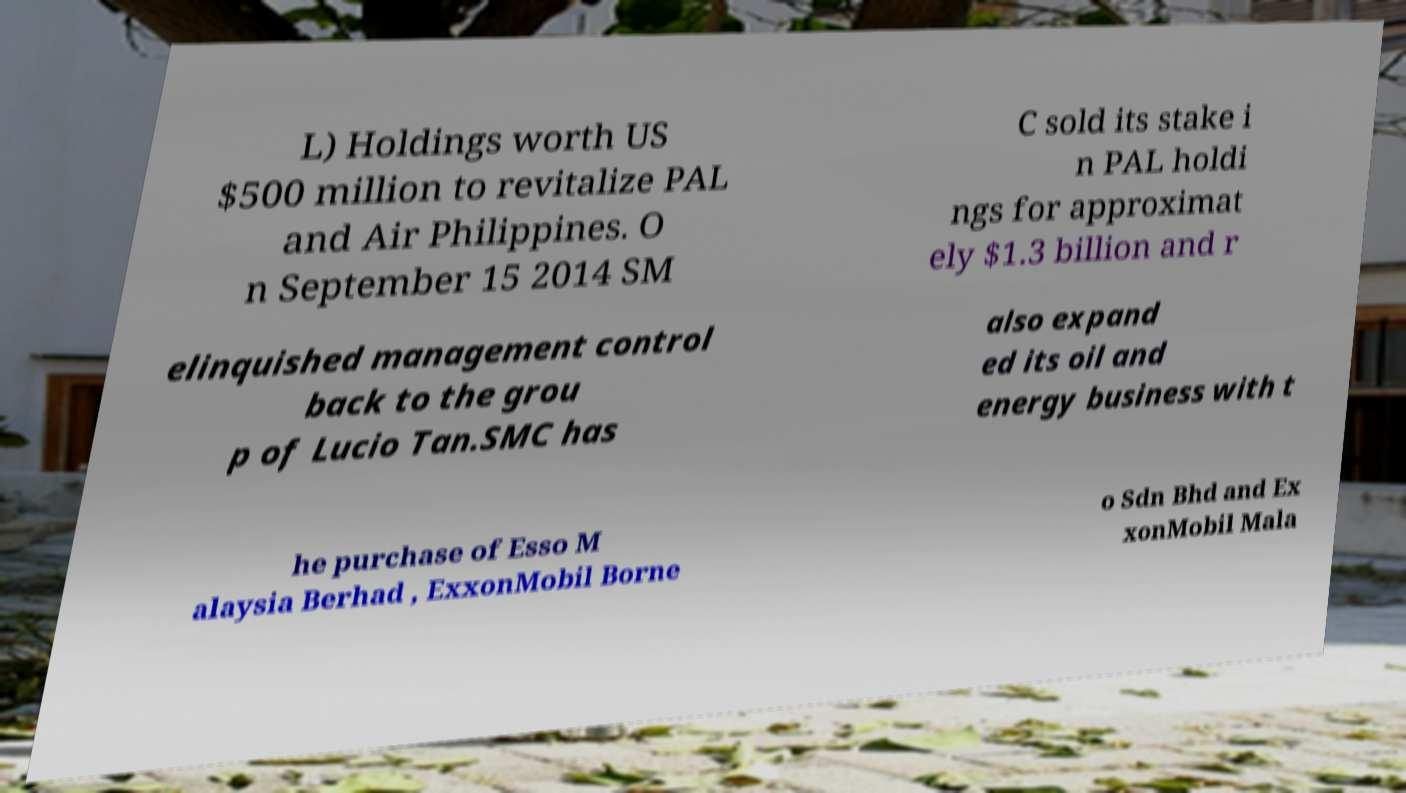Could you extract and type out the text from this image? L) Holdings worth US $500 million to revitalize PAL and Air Philippines. O n September 15 2014 SM C sold its stake i n PAL holdi ngs for approximat ely $1.3 billion and r elinquished management control back to the grou p of Lucio Tan.SMC has also expand ed its oil and energy business with t he purchase of Esso M alaysia Berhad , ExxonMobil Borne o Sdn Bhd and Ex xonMobil Mala 